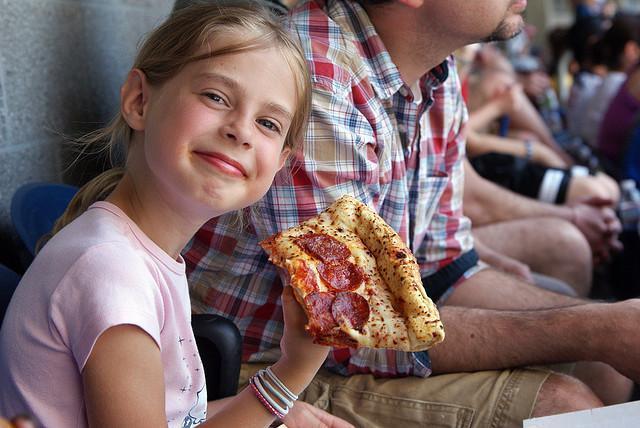How many people are visible?
Give a very brief answer. 6. How many cats are there?
Give a very brief answer. 0. 